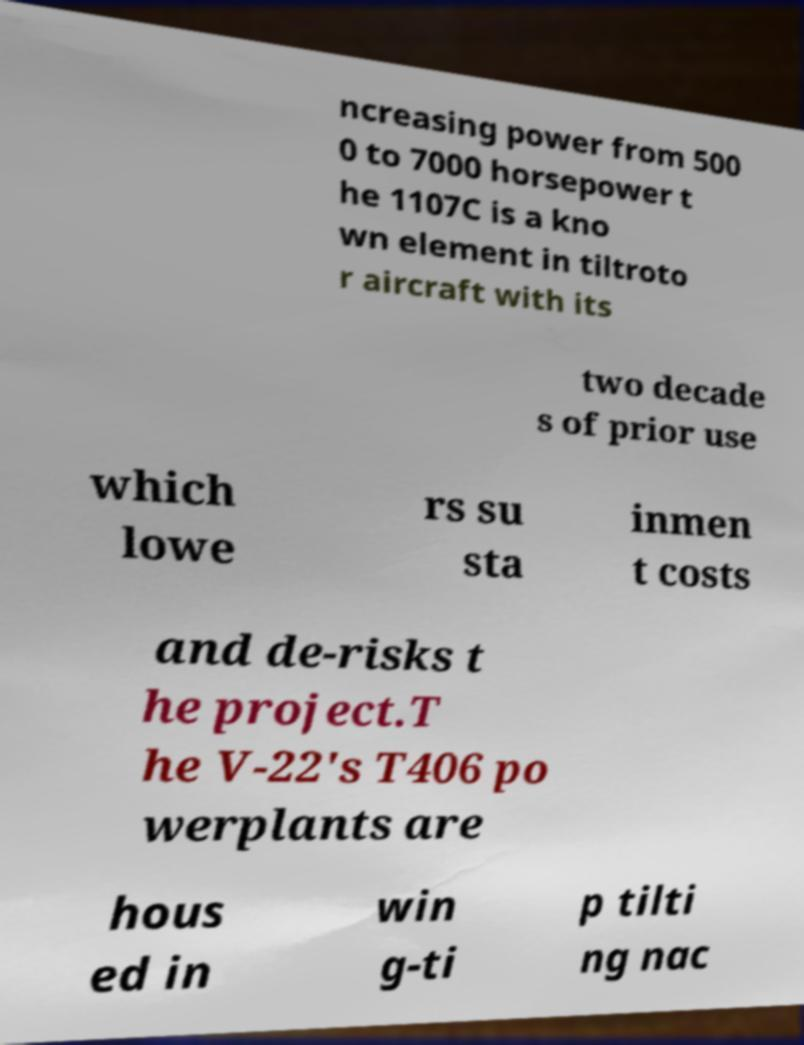What messages or text are displayed in this image? I need them in a readable, typed format. ncreasing power from 500 0 to 7000 horsepower t he 1107C is a kno wn element in tiltroto r aircraft with its two decade s of prior use which lowe rs su sta inmen t costs and de-risks t he project.T he V-22's T406 po werplants are hous ed in win g-ti p tilti ng nac 